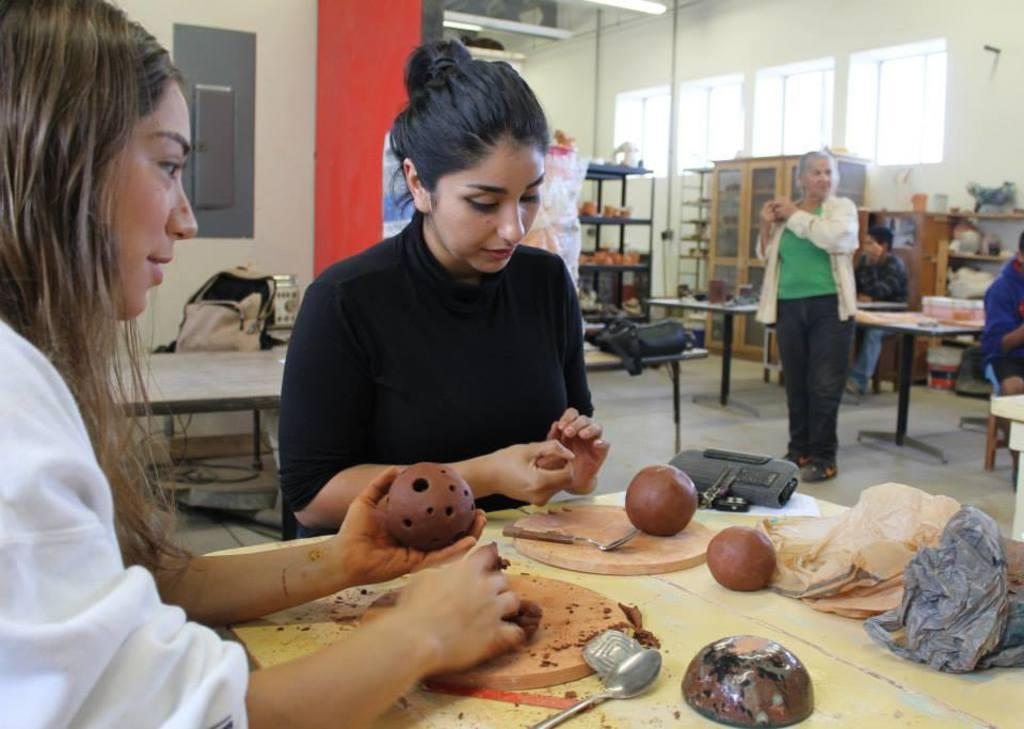How many people are in the image? There are persons in the image, but the exact number cannot be determined from the provided facts. What type of furniture is present in the image? There are tables in the image. What items can be seen that might be used for carrying or storing items? There are bags and cupboards in the image. What type of covering is present in the image? There are plastic covers in the image. What utensils are visible in the image? There are spoons in the image. What type of objects can be seen in the image? There are objects in the image, but their specific nature cannot be determined from the provided facts. What architectural feature is present in the image? There is a rack in the image. What type of openings are visible in the image? There are windows in the image. What is visible in the background of the image? There is a wall in the background of the image. What type of butter is being taught during recess in the image? There is no butter, teaching, or recess present in the image. 